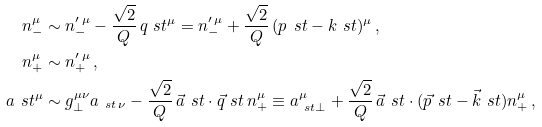Convert formula to latex. <formula><loc_0><loc_0><loc_500><loc_500>n _ { - } ^ { \mu } & \sim n _ { - } ^ { \prime \, \mu } - \frac { \sqrt { 2 } } { Q } \, q _ { \ } s t ^ { \mu } = n _ { - } ^ { \prime \, \mu } + \frac { \sqrt { 2 } } { Q } \, ( p _ { \ } s t - k _ { \ } s t ) ^ { \mu } \, , \\ n _ { + } ^ { \mu } & \sim n _ { + } ^ { \prime \, \mu } \, , \\ a _ { \ } s t ^ { \mu } & \sim g _ { \perp } ^ { \mu \nu } a _ { \ s t \, \nu } - \frac { \sqrt { 2 } } { Q } \, \vec { a } _ { \ } s t \cdot \vec { q } _ { \ } s t \, n _ { + } ^ { \mu } \equiv a _ { \ s t \perp } ^ { \mu } + \frac { \sqrt { 2 } } { Q } \, \vec { a } _ { \ } s t \cdot ( \vec { p } _ { \ } s t - \vec { k } _ { \ } s t ) n _ { + } ^ { \mu } \, ,</formula> 